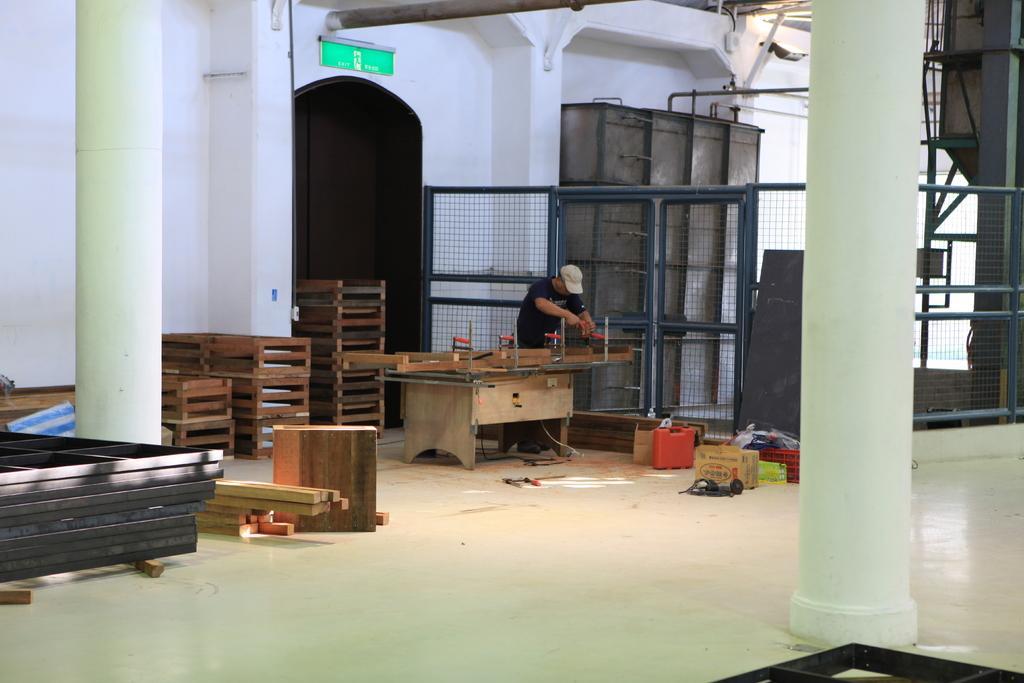Can you describe this image briefly? In this image I can see a person is holding something. In front I can see a wood on the table. Back I can see few wooden racks,wooden logs,cardboard box and few objects on the floor. I can see a fencing and a white wall. 